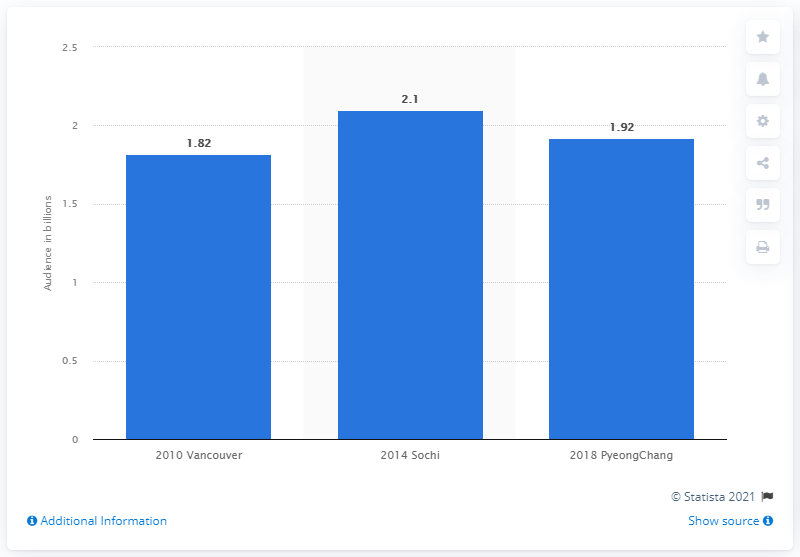Give some essential details in this illustration. The global audience of the 2018 Winter Olympics in PyeongChang was estimated to be 1.92 billion people. 